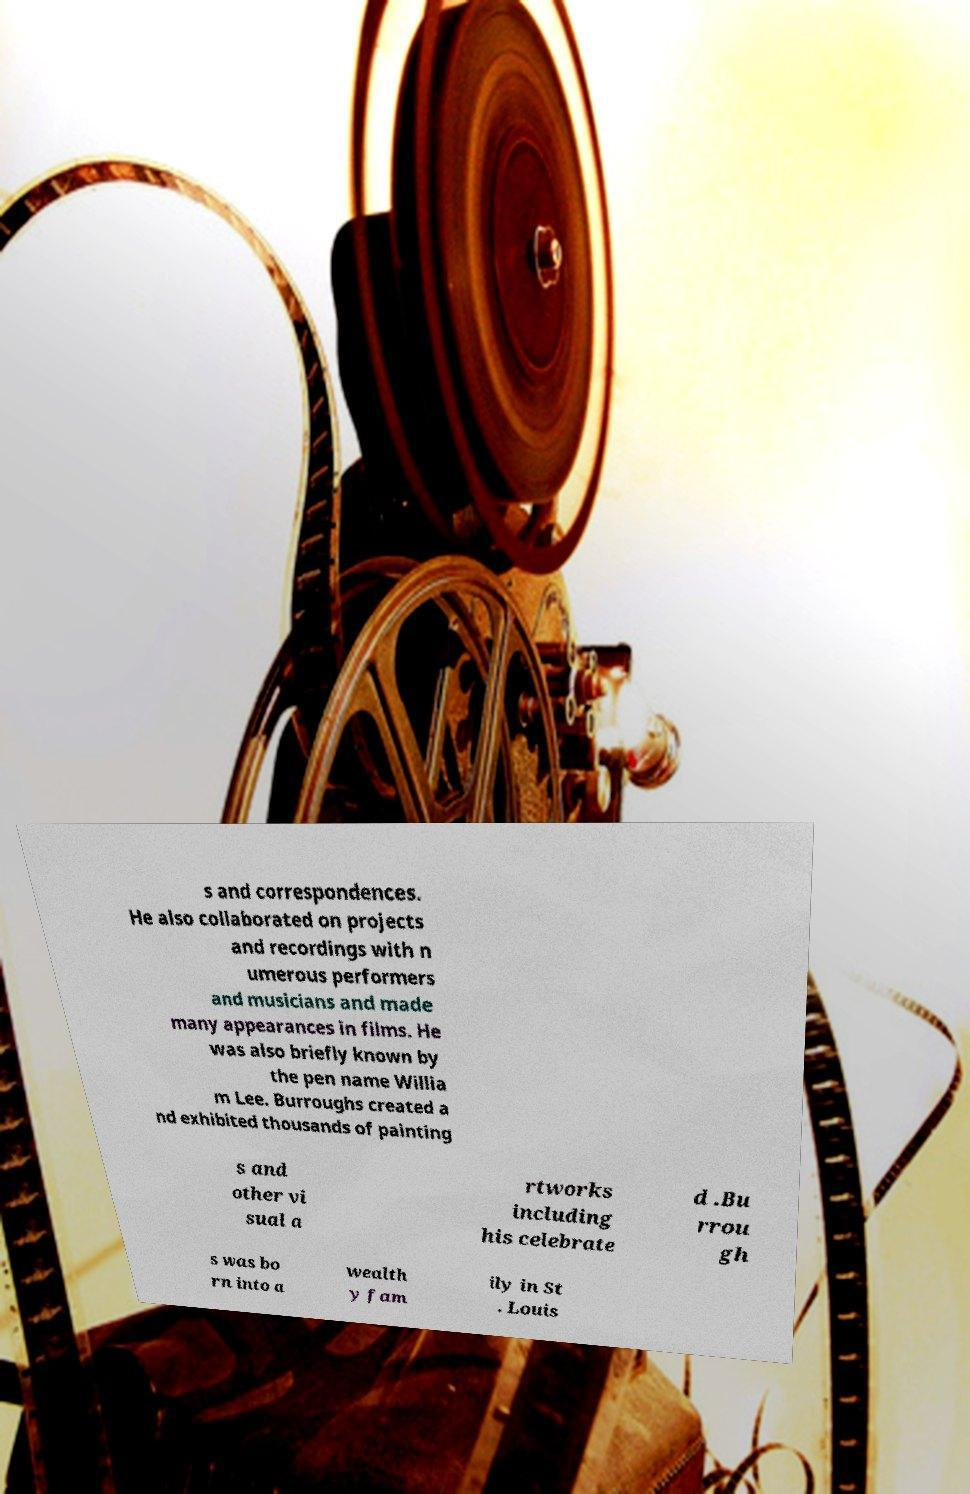I need the written content from this picture converted into text. Can you do that? s and correspondences. He also collaborated on projects and recordings with n umerous performers and musicians and made many appearances in films. He was also briefly known by the pen name Willia m Lee. Burroughs created a nd exhibited thousands of painting s and other vi sual a rtworks including his celebrate d .Bu rrou gh s was bo rn into a wealth y fam ily in St . Louis 